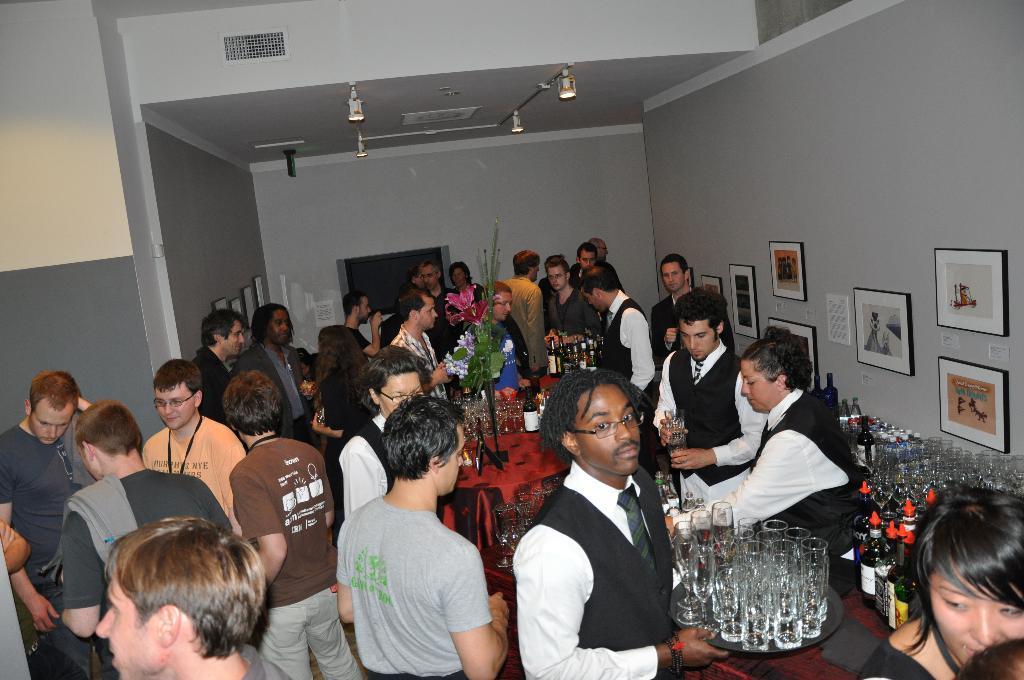Could you give a brief overview of what you see in this image? There are group of people standing among them this man holding plate with glasses. We can see bottles, glasses, flower bouquet and objects on table. We can see frames on walls. At the top we can see lights. 